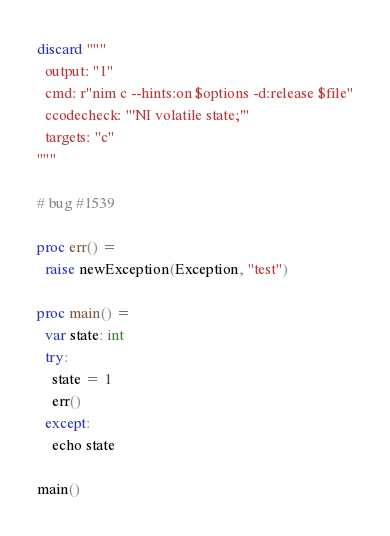Convert code to text. <code><loc_0><loc_0><loc_500><loc_500><_Nim_>discard """
  output: "1"
  cmd: r"nim c --hints:on $options -d:release $file"
  ccodecheck: "'NI volatile state;'"
  targets: "c"
"""

# bug #1539

proc err() =
  raise newException(Exception, "test")

proc main() =
  var state: int
  try:
    state = 1
    err()
  except:
    echo state

main()
</code> 